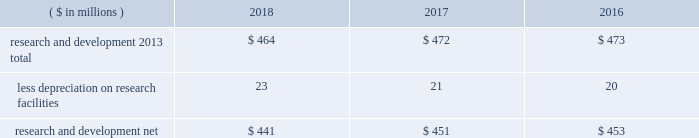52 2018 ppg annual report and 10-k 1 .
Summary of significant accounting policies principles of consolidation the accompanying consolidated financial statements include the accounts of ppg industries , inc .
( 201cppg 201d or the 201ccompany 201d ) and all subsidiaries , both u.s .
And non-u.s. , that it controls .
Ppg owns more than 50% ( 50 % ) of the voting stock of most of the subsidiaries that it controls .
For those consolidated subsidiaries in which the company 2019s ownership is less than 100% ( 100 % ) , the outside shareholders 2019 interests are shown as noncontrolling interests .
Investments in companies in which ppg owns 20% ( 20 % ) to 50% ( 50 % ) of the voting stock and has the ability to exercise significant influence over operating and financial policies of the investee are accounted for using the equity method of accounting .
As a result , ppg 2019s share of income or losses from such equity affiliates is included in the consolidated statement of income and ppg 2019s share of these companies 2019 shareholders 2019 equity is included in investments on the consolidated balance sheet .
Transactions between ppg and its subsidiaries are eliminated in consolidation .
Use of estimates in the preparation of financial statements the preparation of financial statements in conformity with u.s .
Generally accepted accounting principles requires management to make estimates and assumptions that affect the reported amounts of assets and liabilities and the disclosure of contingent assets and liabilities at the date of the financial statements , as well as the reported amounts of income and expenses during the reporting period .
Such estimates also include the fair value of assets acquired and liabilities assumed resulting from the allocation of the purchase price related to business combinations consummated .
Actual outcomes could differ from those estimates .
Revenue recognition revenue is recognized as performance obligations with the customer are satisfied , at an amount that is determined to be collectible .
For the sale of products , this generally occurs at the point in time when control of the company 2019s products transfers to the customer based on the agreed upon shipping terms .
Shipping and handling costs amounts billed to customers for shipping and handling are reported in net sales in the consolidated statement of income .
Shipping and handling costs incurred by the company for the delivery of goods to customers are included in cost of sales , exclusive of depreciation and amortization in the consolidated statement of income .
Selling , general and administrative costs amounts presented in selling , general and administrative in the consolidated statement of income are comprised of selling , customer service , distribution and advertising costs , as well as the costs of providing corporate-wide functional support in such areas as finance , law , human resources and planning .
Distribution costs pertain to the movement and storage of finished goods inventory at company-owned and leased warehouses and other distribution facilities .
Advertising costs advertising costs are expensed as incurred and totaled $ 280 million , $ 313 million and $ 322 million in 2018 , 2017 and 2016 , respectively .
Research and development research and development costs , which consist primarily of employee related costs , are charged to expense as incurred. .
Legal costs legal costs , primarily include costs associated with acquisition and divestiture transactions , general litigation , environmental regulation compliance , patent and trademark protection and other general corporate purposes , are charged to expense as incurred .
Income taxes income taxes are accounted for under the asset and liability method .
Deferred tax assets and liabilities are recognized for the future tax consequences attributable to operating losses and tax credit carryforwards as well as differences between the financial statement carrying amounts of existing assets and liabilities and their respective tax bases .
The effect on deferred notes to the consolidated financial statements .
Were 2017 advertising costs greater than r&d expenses? 
Computations: (313 > 472)
Answer: no. 